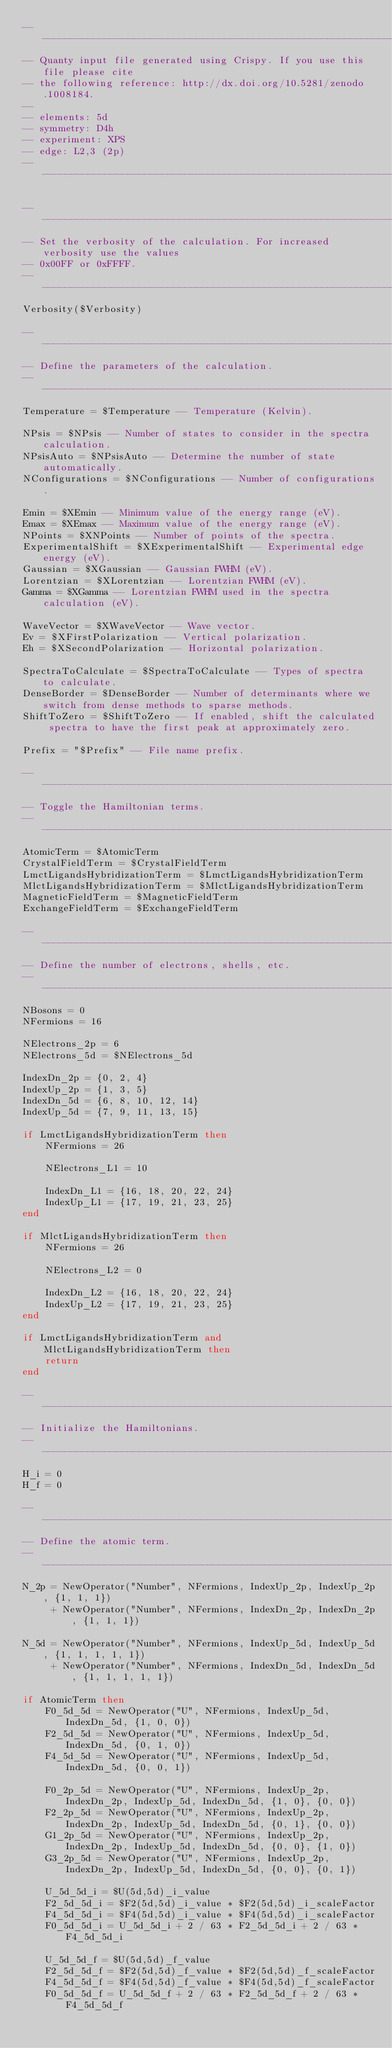<code> <loc_0><loc_0><loc_500><loc_500><_Lua_>--------------------------------------------------------------------------------
-- Quanty input file generated using Crispy. If you use this file please cite
-- the following reference: http://dx.doi.org/10.5281/zenodo.1008184.
--
-- elements: 5d
-- symmetry: D4h
-- experiment: XPS
-- edge: L2,3 (2p)
--------------------------------------------------------------------------------

--------------------------------------------------------------------------------
-- Set the verbosity of the calculation. For increased verbosity use the values
-- 0x00FF or 0xFFFF.
--------------------------------------------------------------------------------
Verbosity($Verbosity)

--------------------------------------------------------------------------------
-- Define the parameters of the calculation.
--------------------------------------------------------------------------------
Temperature = $Temperature -- Temperature (Kelvin).

NPsis = $NPsis -- Number of states to consider in the spectra calculation.
NPsisAuto = $NPsisAuto -- Determine the number of state automatically.
NConfigurations = $NConfigurations -- Number of configurations.

Emin = $XEmin -- Minimum value of the energy range (eV).
Emax = $XEmax -- Maximum value of the energy range (eV).
NPoints = $XNPoints -- Number of points of the spectra.
ExperimentalShift = $XExperimentalShift -- Experimental edge energy (eV).
Gaussian = $XGaussian -- Gaussian FWHM (eV).
Lorentzian = $XLorentzian -- Lorentzian FWHM (eV).
Gamma = $XGamma -- Lorentzian FWHM used in the spectra calculation (eV).

WaveVector = $XWaveVector -- Wave vector.
Ev = $XFirstPolarization -- Vertical polarization.
Eh = $XSecondPolarization -- Horizontal polarization.

SpectraToCalculate = $SpectraToCalculate -- Types of spectra to calculate.
DenseBorder = $DenseBorder -- Number of determinants where we switch from dense methods to sparse methods.
ShiftToZero = $ShiftToZero -- If enabled, shift the calculated spectra to have the first peak at approximately zero.

Prefix = "$Prefix" -- File name prefix.

--------------------------------------------------------------------------------
-- Toggle the Hamiltonian terms.
--------------------------------------------------------------------------------
AtomicTerm = $AtomicTerm
CrystalFieldTerm = $CrystalFieldTerm
LmctLigandsHybridizationTerm = $LmctLigandsHybridizationTerm
MlctLigandsHybridizationTerm = $MlctLigandsHybridizationTerm
MagneticFieldTerm = $MagneticFieldTerm
ExchangeFieldTerm = $ExchangeFieldTerm

--------------------------------------------------------------------------------
-- Define the number of electrons, shells, etc.
--------------------------------------------------------------------------------
NBosons = 0
NFermions = 16

NElectrons_2p = 6
NElectrons_5d = $NElectrons_5d

IndexDn_2p = {0, 2, 4}
IndexUp_2p = {1, 3, 5}
IndexDn_5d = {6, 8, 10, 12, 14}
IndexUp_5d = {7, 9, 11, 13, 15}

if LmctLigandsHybridizationTerm then
    NFermions = 26

    NElectrons_L1 = 10

    IndexDn_L1 = {16, 18, 20, 22, 24}
    IndexUp_L1 = {17, 19, 21, 23, 25}
end

if MlctLigandsHybridizationTerm then
    NFermions = 26

    NElectrons_L2 = 0

    IndexDn_L2 = {16, 18, 20, 22, 24}
    IndexUp_L2 = {17, 19, 21, 23, 25}
end

if LmctLigandsHybridizationTerm and MlctLigandsHybridizationTerm then
    return
end

--------------------------------------------------------------------------------
-- Initialize the Hamiltonians.
--------------------------------------------------------------------------------
H_i = 0
H_f = 0

--------------------------------------------------------------------------------
-- Define the atomic term.
--------------------------------------------------------------------------------
N_2p = NewOperator("Number", NFermions, IndexUp_2p, IndexUp_2p, {1, 1, 1})
     + NewOperator("Number", NFermions, IndexDn_2p, IndexDn_2p, {1, 1, 1})

N_5d = NewOperator("Number", NFermions, IndexUp_5d, IndexUp_5d, {1, 1, 1, 1, 1})
     + NewOperator("Number", NFermions, IndexDn_5d, IndexDn_5d, {1, 1, 1, 1, 1})

if AtomicTerm then
    F0_5d_5d = NewOperator("U", NFermions, IndexUp_5d, IndexDn_5d, {1, 0, 0})
    F2_5d_5d = NewOperator("U", NFermions, IndexUp_5d, IndexDn_5d, {0, 1, 0})
    F4_5d_5d = NewOperator("U", NFermions, IndexUp_5d, IndexDn_5d, {0, 0, 1})

    F0_2p_5d = NewOperator("U", NFermions, IndexUp_2p, IndexDn_2p, IndexUp_5d, IndexDn_5d, {1, 0}, {0, 0})
    F2_2p_5d = NewOperator("U", NFermions, IndexUp_2p, IndexDn_2p, IndexUp_5d, IndexDn_5d, {0, 1}, {0, 0})
    G1_2p_5d = NewOperator("U", NFermions, IndexUp_2p, IndexDn_2p, IndexUp_5d, IndexDn_5d, {0, 0}, {1, 0})
    G3_2p_5d = NewOperator("U", NFermions, IndexUp_2p, IndexDn_2p, IndexUp_5d, IndexDn_5d, {0, 0}, {0, 1})

    U_5d_5d_i = $U(5d,5d)_i_value
    F2_5d_5d_i = $F2(5d,5d)_i_value * $F2(5d,5d)_i_scaleFactor
    F4_5d_5d_i = $F4(5d,5d)_i_value * $F4(5d,5d)_i_scaleFactor
    F0_5d_5d_i = U_5d_5d_i + 2 / 63 * F2_5d_5d_i + 2 / 63 * F4_5d_5d_i

    U_5d_5d_f = $U(5d,5d)_f_value
    F2_5d_5d_f = $F2(5d,5d)_f_value * $F2(5d,5d)_f_scaleFactor
    F4_5d_5d_f = $F4(5d,5d)_f_value * $F4(5d,5d)_f_scaleFactor
    F0_5d_5d_f = U_5d_5d_f + 2 / 63 * F2_5d_5d_f + 2 / 63 * F4_5d_5d_f</code> 